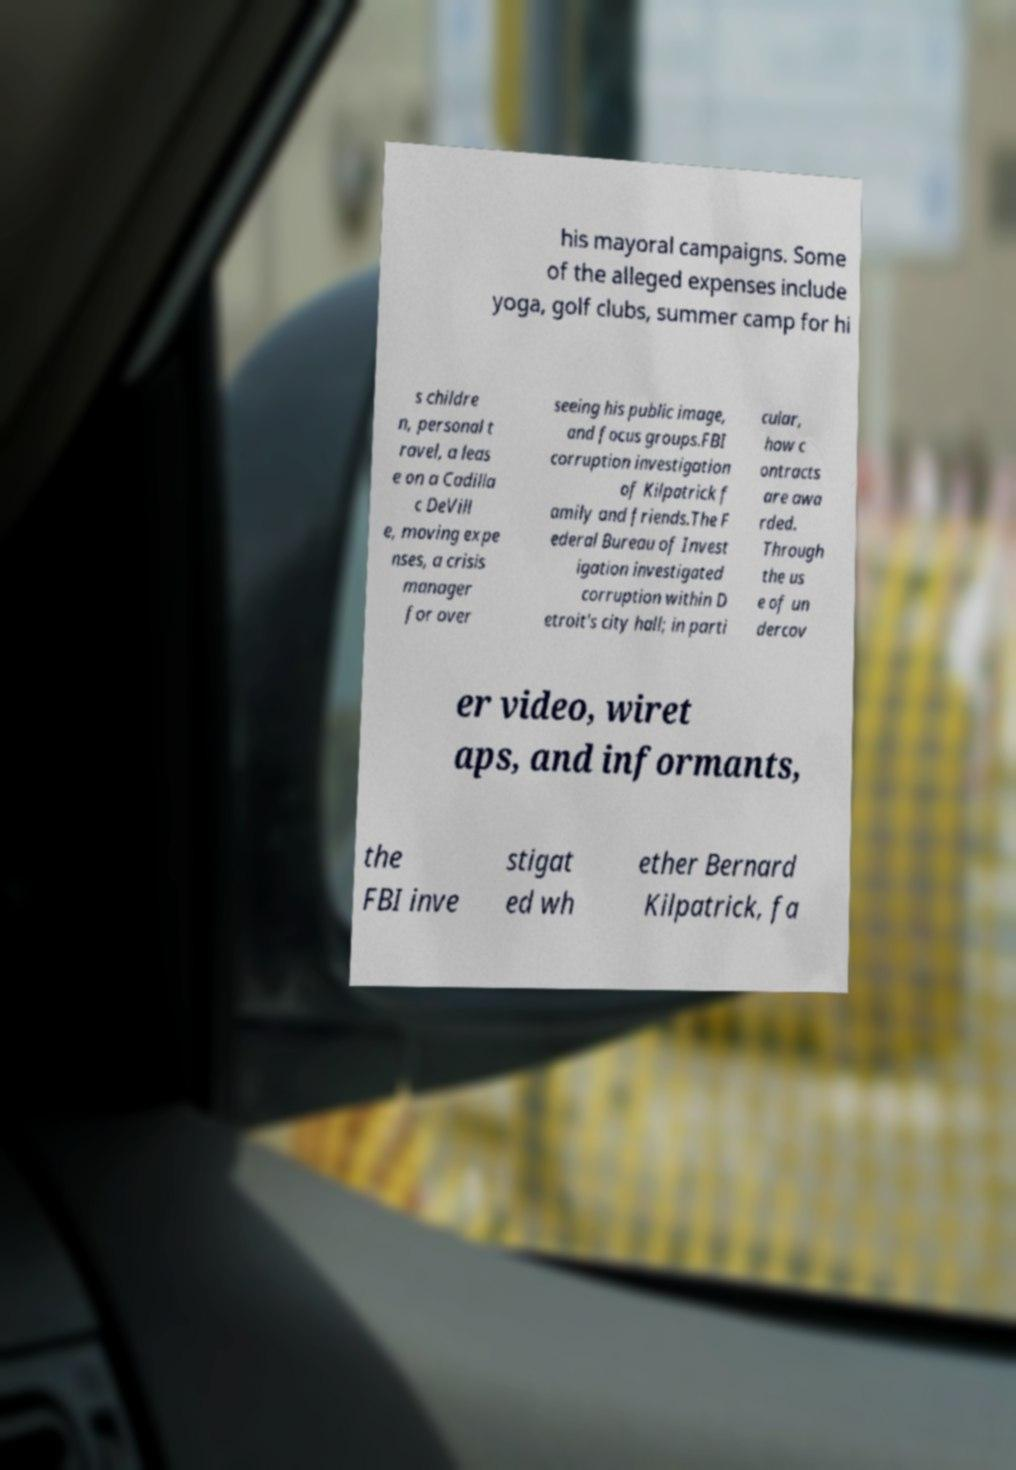Please identify and transcribe the text found in this image. his mayoral campaigns. Some of the alleged expenses include yoga, golf clubs, summer camp for hi s childre n, personal t ravel, a leas e on a Cadilla c DeVill e, moving expe nses, a crisis manager for over seeing his public image, and focus groups.FBI corruption investigation of Kilpatrick f amily and friends.The F ederal Bureau of Invest igation investigated corruption within D etroit's city hall; in parti cular, how c ontracts are awa rded. Through the us e of un dercov er video, wiret aps, and informants, the FBI inve stigat ed wh ether Bernard Kilpatrick, fa 